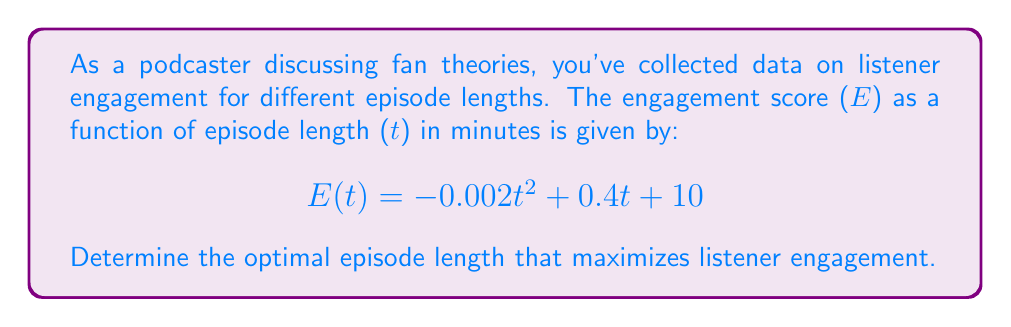Can you solve this math problem? To find the optimal episode length that maximizes listener engagement, we need to follow these steps:

1) The engagement score function E(t) is a quadratic function. The graph of this function is a parabola that opens downward because the coefficient of t^2 is negative.

2) The maximum point of a parabola occurs at the vertex. For a quadratic function in the form $f(t) = at^2 + bt + c$, the t-coordinate of the vertex is given by $t = -\frac{b}{2a}$.

3) In our function, $E(t) = -0.002t^2 + 0.4t + 10$, we have:
   $a = -0.002$
   $b = 0.4$
   $c = 10$

4) Applying the formula:
   $$t = -\frac{b}{2a} = -\frac{0.4}{2(-0.002)} = -\frac{0.4}{-0.004} = 100$$

5) Therefore, the optimal episode length is 100 minutes.

6) To verify, we can calculate the engagement score for t = 99, 100, and 101:
   $E(99) = -0.002(99)^2 + 0.4(99) + 10 = 29.9802$
   $E(100) = -0.002(100)^2 + 0.4(100) + 10 = 30$
   $E(101) = -0.002(101)^2 + 0.4(101) + 10 = 29.9998$

   This confirms that 100 minutes gives the maximum engagement score.
Answer: 100 minutes 